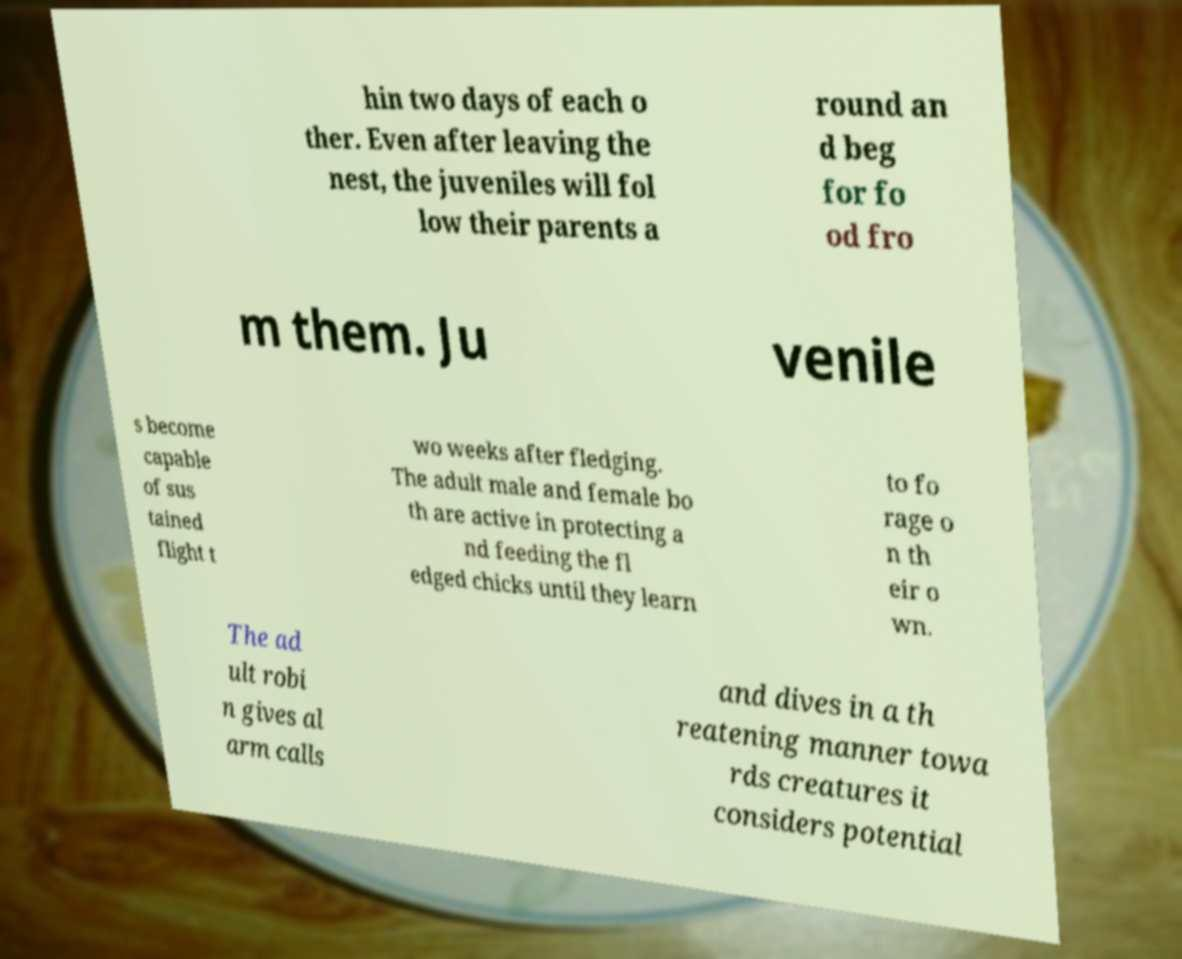Could you assist in decoding the text presented in this image and type it out clearly? hin two days of each o ther. Even after leaving the nest, the juveniles will fol low their parents a round an d beg for fo od fro m them. Ju venile s become capable of sus tained flight t wo weeks after fledging. The adult male and female bo th are active in protecting a nd feeding the fl edged chicks until they learn to fo rage o n th eir o wn. The ad ult robi n gives al arm calls and dives in a th reatening manner towa rds creatures it considers potential 